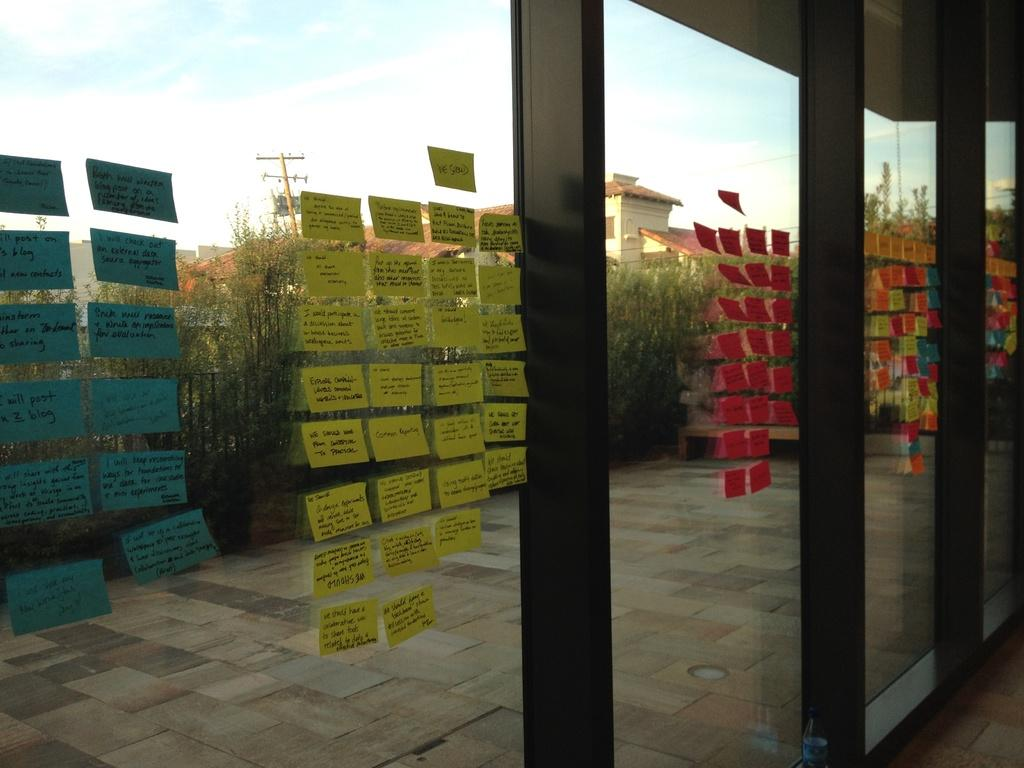What is covering the glass window panes in the image? There are colorful sticky notes on the glass window panes. What can be seen in the background of the image? Trees and houses are visible in the background. What type of veil can be seen hanging from the trees in the image? There is no veil present in the image; only trees and houses are visible in the background. 